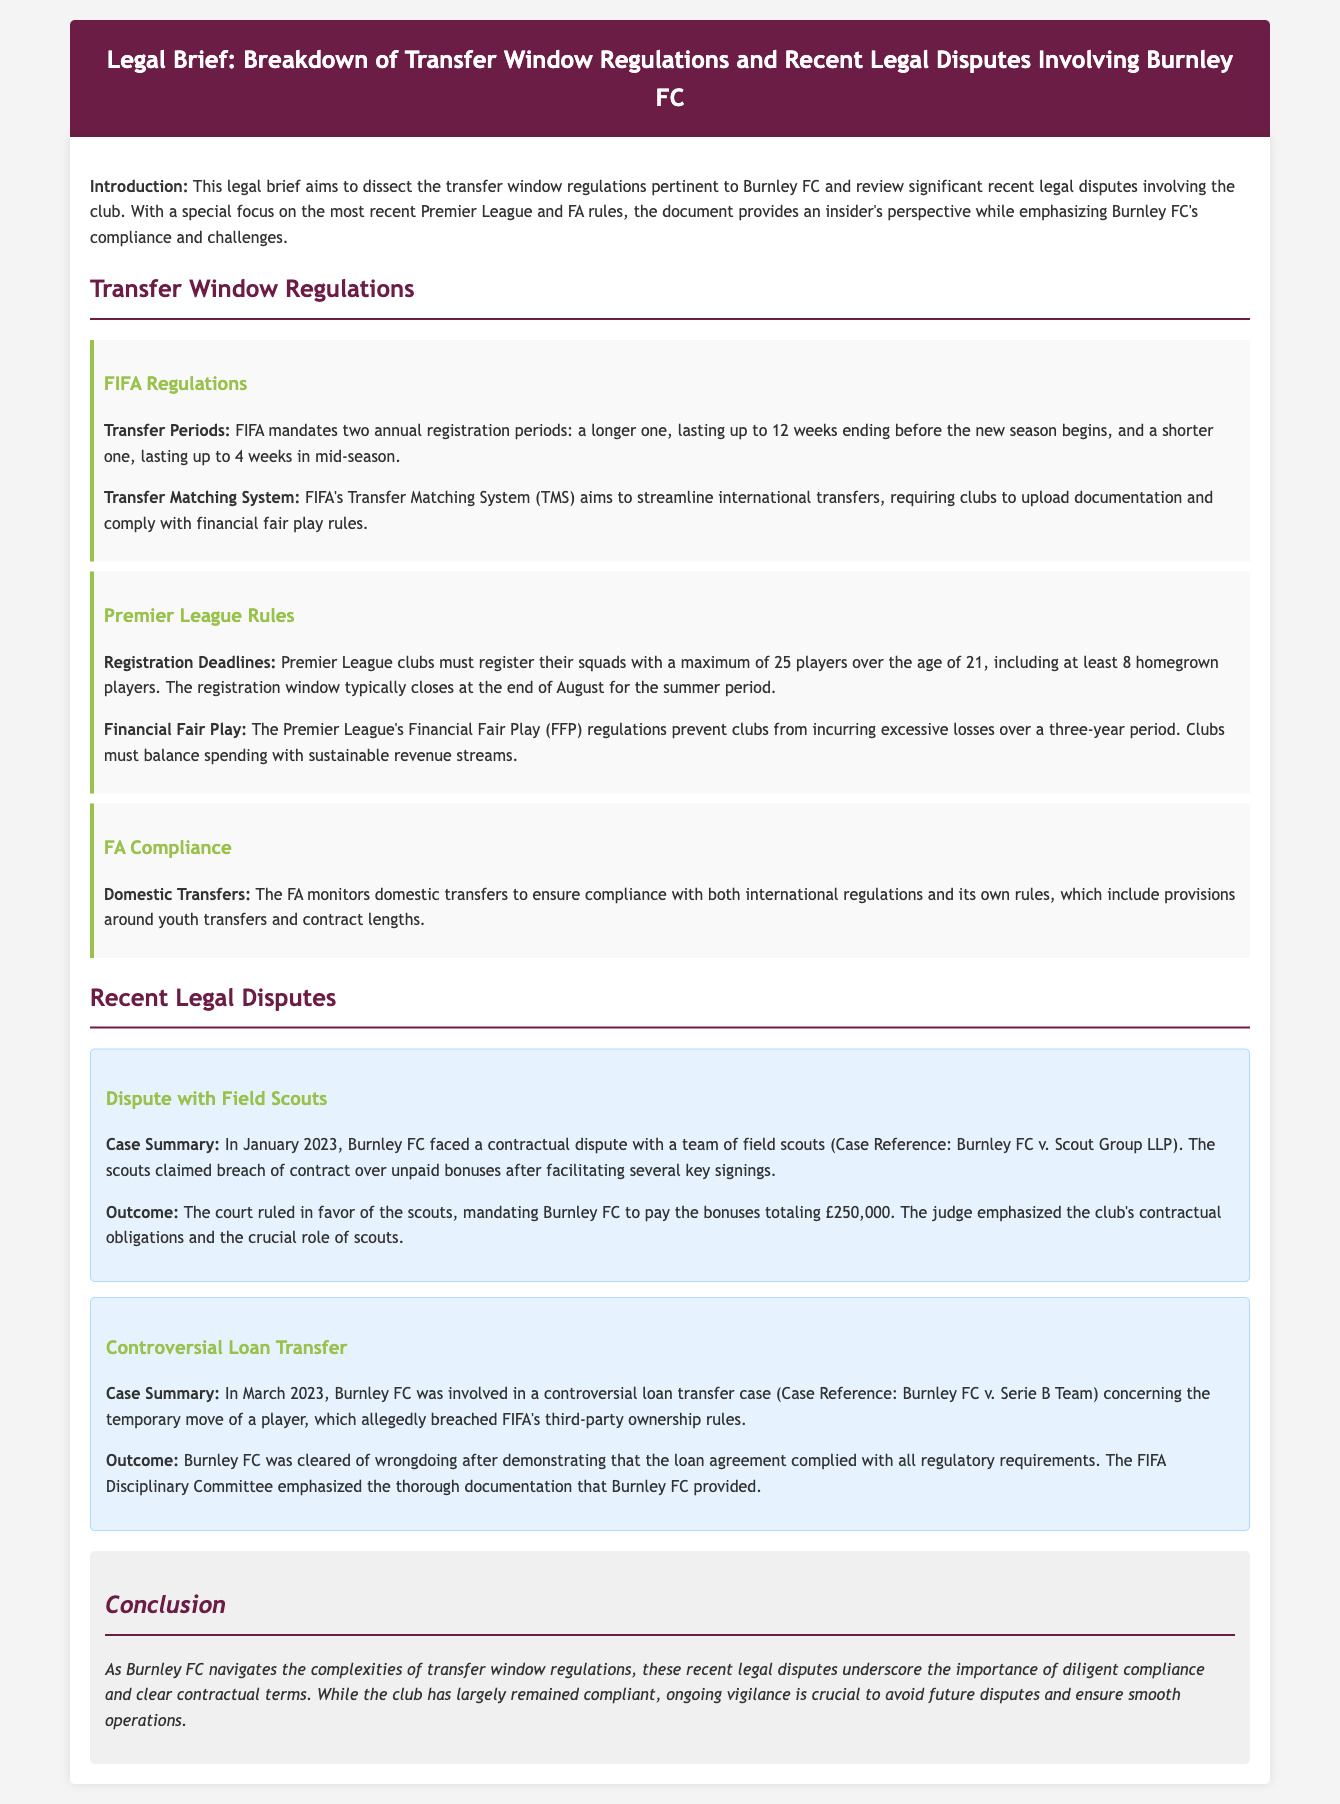What are the two annual registration periods mandated by FIFA? FIFA mandates a longer one lasting up to 12 weeks and a shorter one lasting up to 4 weeks.
Answer: 12 weeks and 4 weeks What is the total amount Burnley FC was ordered to pay the scouts? The court ruled in favor of the scouts, ordering Burnley FC to pay bonuses totaling £250,000.
Answer: £250,000 When was the loan transfer case involving Burnley FC? The loan transfer case occurred in March 2023.
Answer: March 2023 What must Premier League clubs register regarding players? Clubs must register a maximum of 25 players over the age of 21, including at least 8 homegrown players.
Answer: 25 players What system does FIFA use to streamline international transfers? FIFA's Transfer Matching System (TMS) is used to streamline international transfers.
Answer: Transfer Matching System What was emphasized by the judge in the dispute case involving the scouts? The judge emphasized the club's contractual obligations and the crucial role of scouts.
Answer: Contractual obligations What document type is this legal brief categorized under? This is categorized as a legal brief focusing on transfer window regulations and legal disputes.
Answer: Legal brief What did the FIFA Disciplinary Committee emphasize in the loan agreement case? They emphasized the thorough documentation that Burnley FC provided.
Answer: Thorough documentation What is the focus of the conclusion in the document? The conclusion focuses on the importance of diligent compliance and clear contractual terms for Burnley FC.
Answer: Diligent compliance and clear contractual terms 